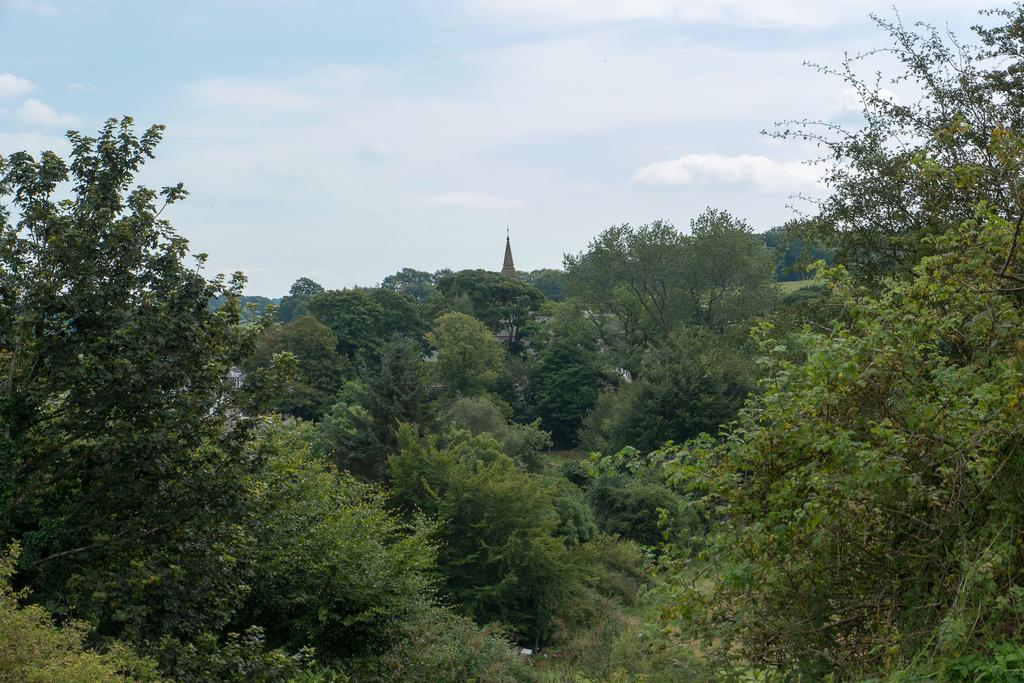What type of vegetation can be seen in the image? There are trees in the image. What structure is present in the image? There is a tower in the image. What is visible in the background of the image? The sky is visible in the background of the image. What can be observed in the sky? Clouds are present in the sky. What advice does the uncle give during the recess in the image? There is no uncle or recess present in the image. What type of shock is depicted in the image? There is no shock depicted in the image; it features trees, a tower, and a sky with clouds. 